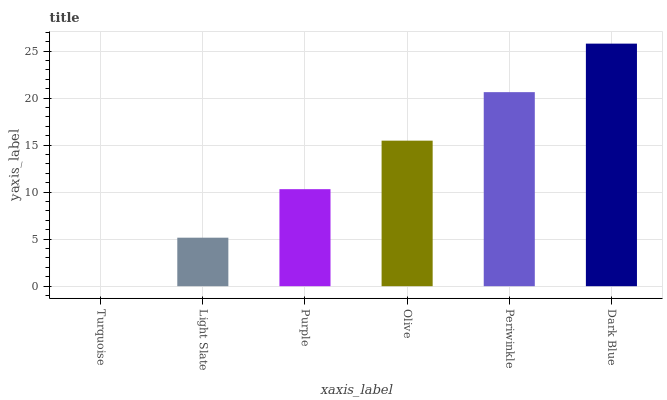Is Turquoise the minimum?
Answer yes or no. Yes. Is Dark Blue the maximum?
Answer yes or no. Yes. Is Light Slate the minimum?
Answer yes or no. No. Is Light Slate the maximum?
Answer yes or no. No. Is Light Slate greater than Turquoise?
Answer yes or no. Yes. Is Turquoise less than Light Slate?
Answer yes or no. Yes. Is Turquoise greater than Light Slate?
Answer yes or no. No. Is Light Slate less than Turquoise?
Answer yes or no. No. Is Olive the high median?
Answer yes or no. Yes. Is Purple the low median?
Answer yes or no. Yes. Is Turquoise the high median?
Answer yes or no. No. Is Turquoise the low median?
Answer yes or no. No. 